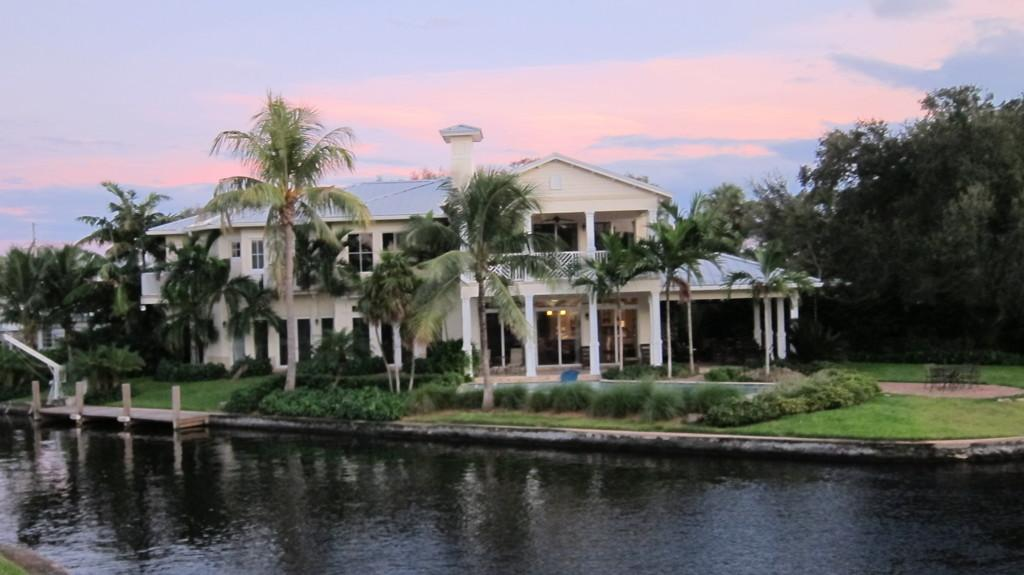What is the primary element visible in the image? There is water in the image. What type of vegetation can be seen in the image? There is grass and trees in the image. What type of structure is present in the image? There is a white building in the image. How does the zipper function in the image? There is no zipper present in the image. 